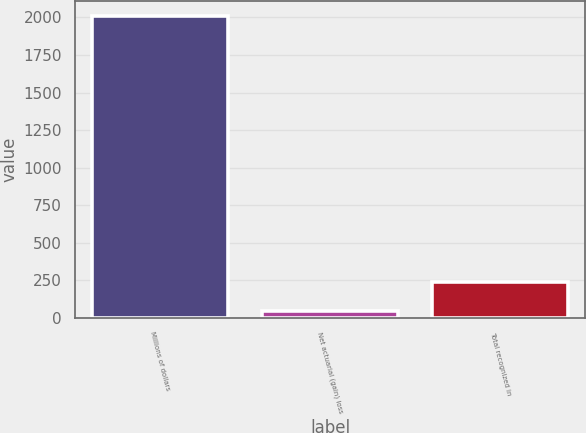Convert chart to OTSL. <chart><loc_0><loc_0><loc_500><loc_500><bar_chart><fcel>Millions of dollars<fcel>Net actuarial (gain) loss<fcel>Total recognized in<nl><fcel>2008<fcel>43<fcel>239.5<nl></chart> 